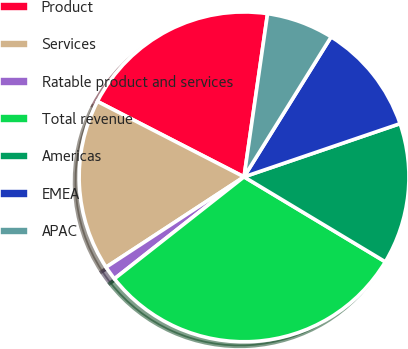Convert chart. <chart><loc_0><loc_0><loc_500><loc_500><pie_chart><fcel>Product<fcel>Services<fcel>Ratable product and services<fcel>Total revenue<fcel>Americas<fcel>EMEA<fcel>APAC<nl><fcel>19.72%<fcel>16.79%<fcel>1.38%<fcel>30.78%<fcel>13.85%<fcel>10.91%<fcel>6.58%<nl></chart> 